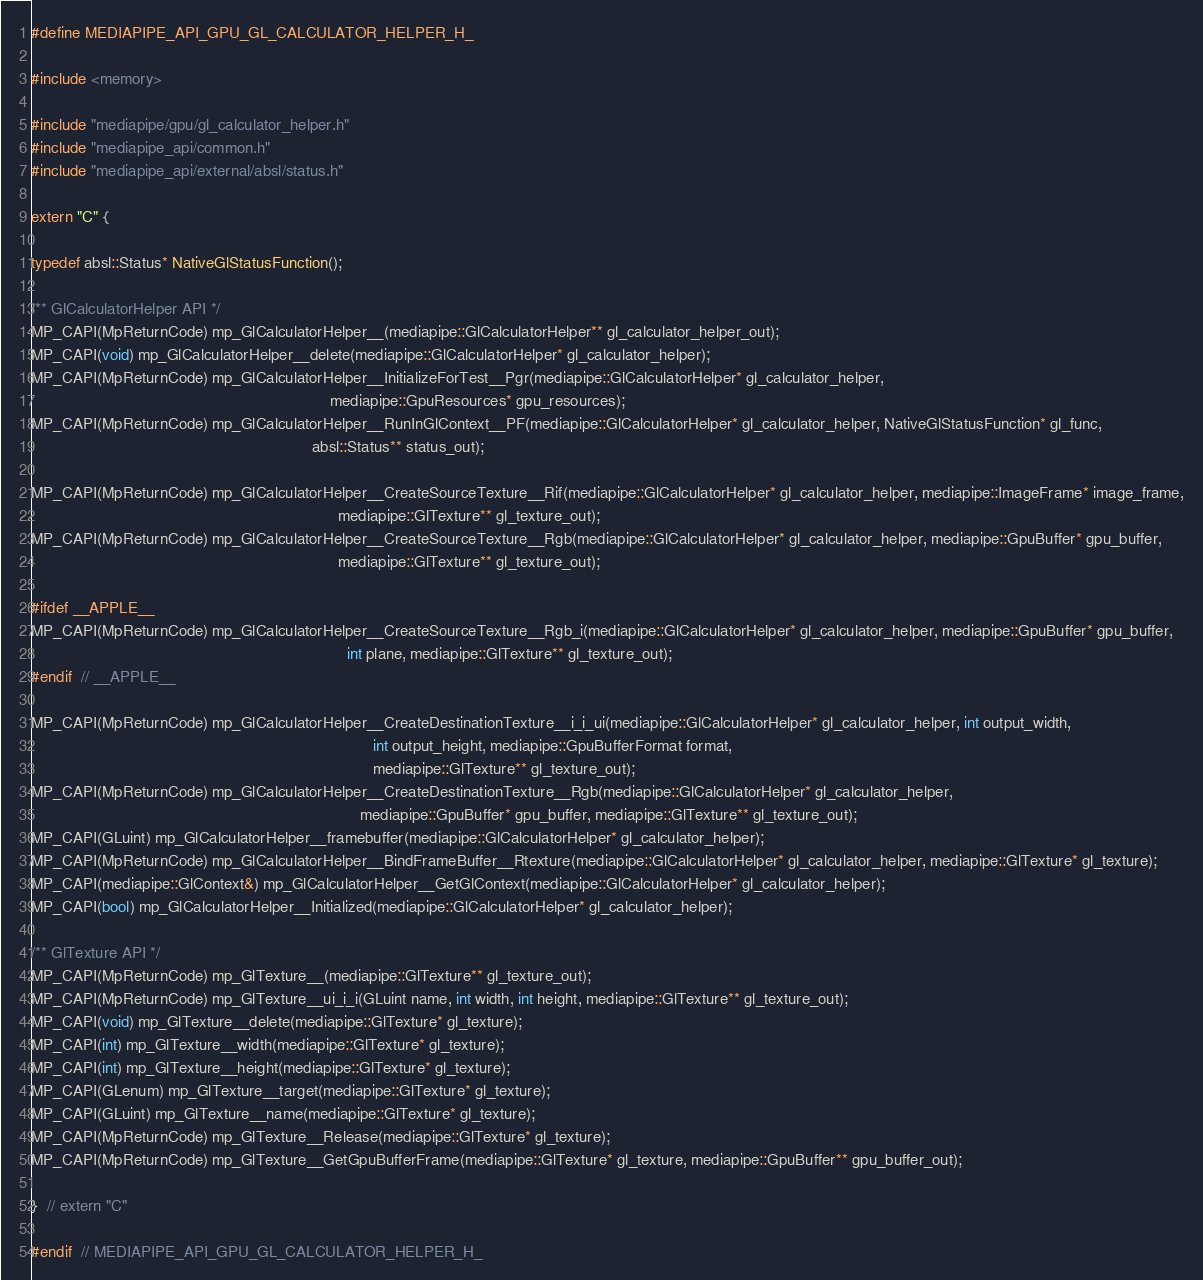Convert code to text. <code><loc_0><loc_0><loc_500><loc_500><_C_>#define MEDIAPIPE_API_GPU_GL_CALCULATOR_HELPER_H_

#include <memory>

#include "mediapipe/gpu/gl_calculator_helper.h"
#include "mediapipe_api/common.h"
#include "mediapipe_api/external/absl/status.h"

extern "C" {

typedef absl::Status* NativeGlStatusFunction();

/** GlCalculatorHelper API */
MP_CAPI(MpReturnCode) mp_GlCalculatorHelper__(mediapipe::GlCalculatorHelper** gl_calculator_helper_out);
MP_CAPI(void) mp_GlCalculatorHelper__delete(mediapipe::GlCalculatorHelper* gl_calculator_helper);
MP_CAPI(MpReturnCode) mp_GlCalculatorHelper__InitializeForTest__Pgr(mediapipe::GlCalculatorHelper* gl_calculator_helper,
                                                                    mediapipe::GpuResources* gpu_resources);
MP_CAPI(MpReturnCode) mp_GlCalculatorHelper__RunInGlContext__PF(mediapipe::GlCalculatorHelper* gl_calculator_helper, NativeGlStatusFunction* gl_func,
                                                                absl::Status** status_out);

MP_CAPI(MpReturnCode) mp_GlCalculatorHelper__CreateSourceTexture__Rif(mediapipe::GlCalculatorHelper* gl_calculator_helper, mediapipe::ImageFrame* image_frame,
                                                                      mediapipe::GlTexture** gl_texture_out);
MP_CAPI(MpReturnCode) mp_GlCalculatorHelper__CreateSourceTexture__Rgb(mediapipe::GlCalculatorHelper* gl_calculator_helper, mediapipe::GpuBuffer* gpu_buffer,
                                                                      mediapipe::GlTexture** gl_texture_out);

#ifdef __APPLE__
MP_CAPI(MpReturnCode) mp_GlCalculatorHelper__CreateSourceTexture__Rgb_i(mediapipe::GlCalculatorHelper* gl_calculator_helper, mediapipe::GpuBuffer* gpu_buffer,
                                                                        int plane, mediapipe::GlTexture** gl_texture_out);
#endif  // __APPLE__

MP_CAPI(MpReturnCode) mp_GlCalculatorHelper__CreateDestinationTexture__i_i_ui(mediapipe::GlCalculatorHelper* gl_calculator_helper, int output_width,
                                                                              int output_height, mediapipe::GpuBufferFormat format,
                                                                              mediapipe::GlTexture** gl_texture_out);
MP_CAPI(MpReturnCode) mp_GlCalculatorHelper__CreateDestinationTexture__Rgb(mediapipe::GlCalculatorHelper* gl_calculator_helper,
                                                                           mediapipe::GpuBuffer* gpu_buffer, mediapipe::GlTexture** gl_texture_out);
MP_CAPI(GLuint) mp_GlCalculatorHelper__framebuffer(mediapipe::GlCalculatorHelper* gl_calculator_helper);
MP_CAPI(MpReturnCode) mp_GlCalculatorHelper__BindFrameBuffer__Rtexture(mediapipe::GlCalculatorHelper* gl_calculator_helper, mediapipe::GlTexture* gl_texture);
MP_CAPI(mediapipe::GlContext&) mp_GlCalculatorHelper__GetGlContext(mediapipe::GlCalculatorHelper* gl_calculator_helper);
MP_CAPI(bool) mp_GlCalculatorHelper__Initialized(mediapipe::GlCalculatorHelper* gl_calculator_helper);

/** GlTexture API */
MP_CAPI(MpReturnCode) mp_GlTexture__(mediapipe::GlTexture** gl_texture_out);
MP_CAPI(MpReturnCode) mp_GlTexture__ui_i_i(GLuint name, int width, int height, mediapipe::GlTexture** gl_texture_out);
MP_CAPI(void) mp_GlTexture__delete(mediapipe::GlTexture* gl_texture);
MP_CAPI(int) mp_GlTexture__width(mediapipe::GlTexture* gl_texture);
MP_CAPI(int) mp_GlTexture__height(mediapipe::GlTexture* gl_texture);
MP_CAPI(GLenum) mp_GlTexture__target(mediapipe::GlTexture* gl_texture);
MP_CAPI(GLuint) mp_GlTexture__name(mediapipe::GlTexture* gl_texture);
MP_CAPI(MpReturnCode) mp_GlTexture__Release(mediapipe::GlTexture* gl_texture);
MP_CAPI(MpReturnCode) mp_GlTexture__GetGpuBufferFrame(mediapipe::GlTexture* gl_texture, mediapipe::GpuBuffer** gpu_buffer_out);

}  // extern "C"

#endif  // MEDIAPIPE_API_GPU_GL_CALCULATOR_HELPER_H_
</code> 